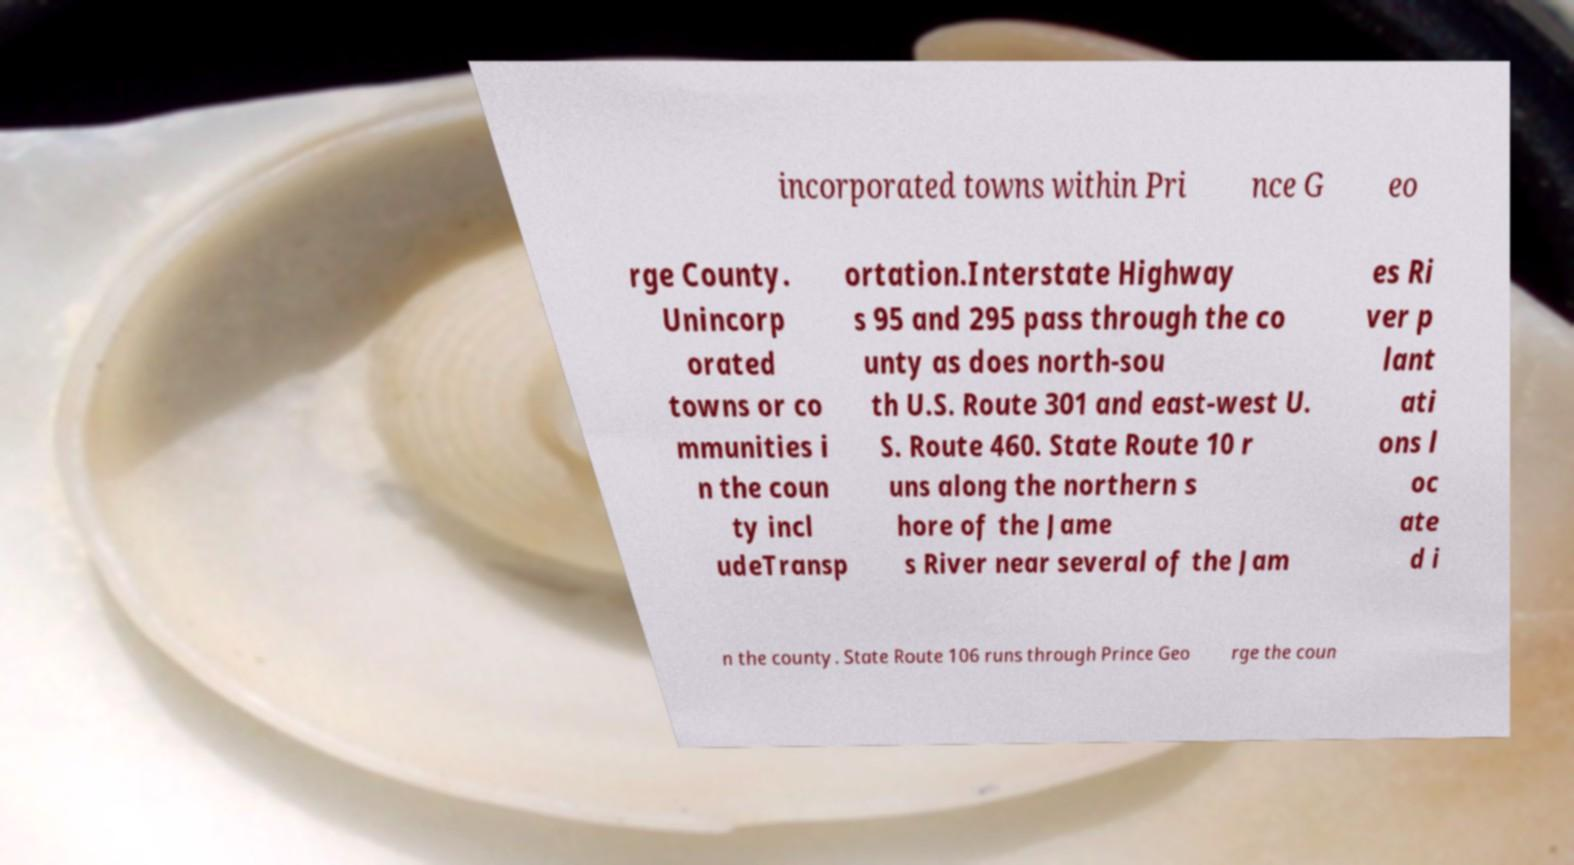What messages or text are displayed in this image? I need them in a readable, typed format. incorporated towns within Pri nce G eo rge County. Unincorp orated towns or co mmunities i n the coun ty incl udeTransp ortation.Interstate Highway s 95 and 295 pass through the co unty as does north-sou th U.S. Route 301 and east-west U. S. Route 460. State Route 10 r uns along the northern s hore of the Jame s River near several of the Jam es Ri ver p lant ati ons l oc ate d i n the county. State Route 106 runs through Prince Geo rge the coun 